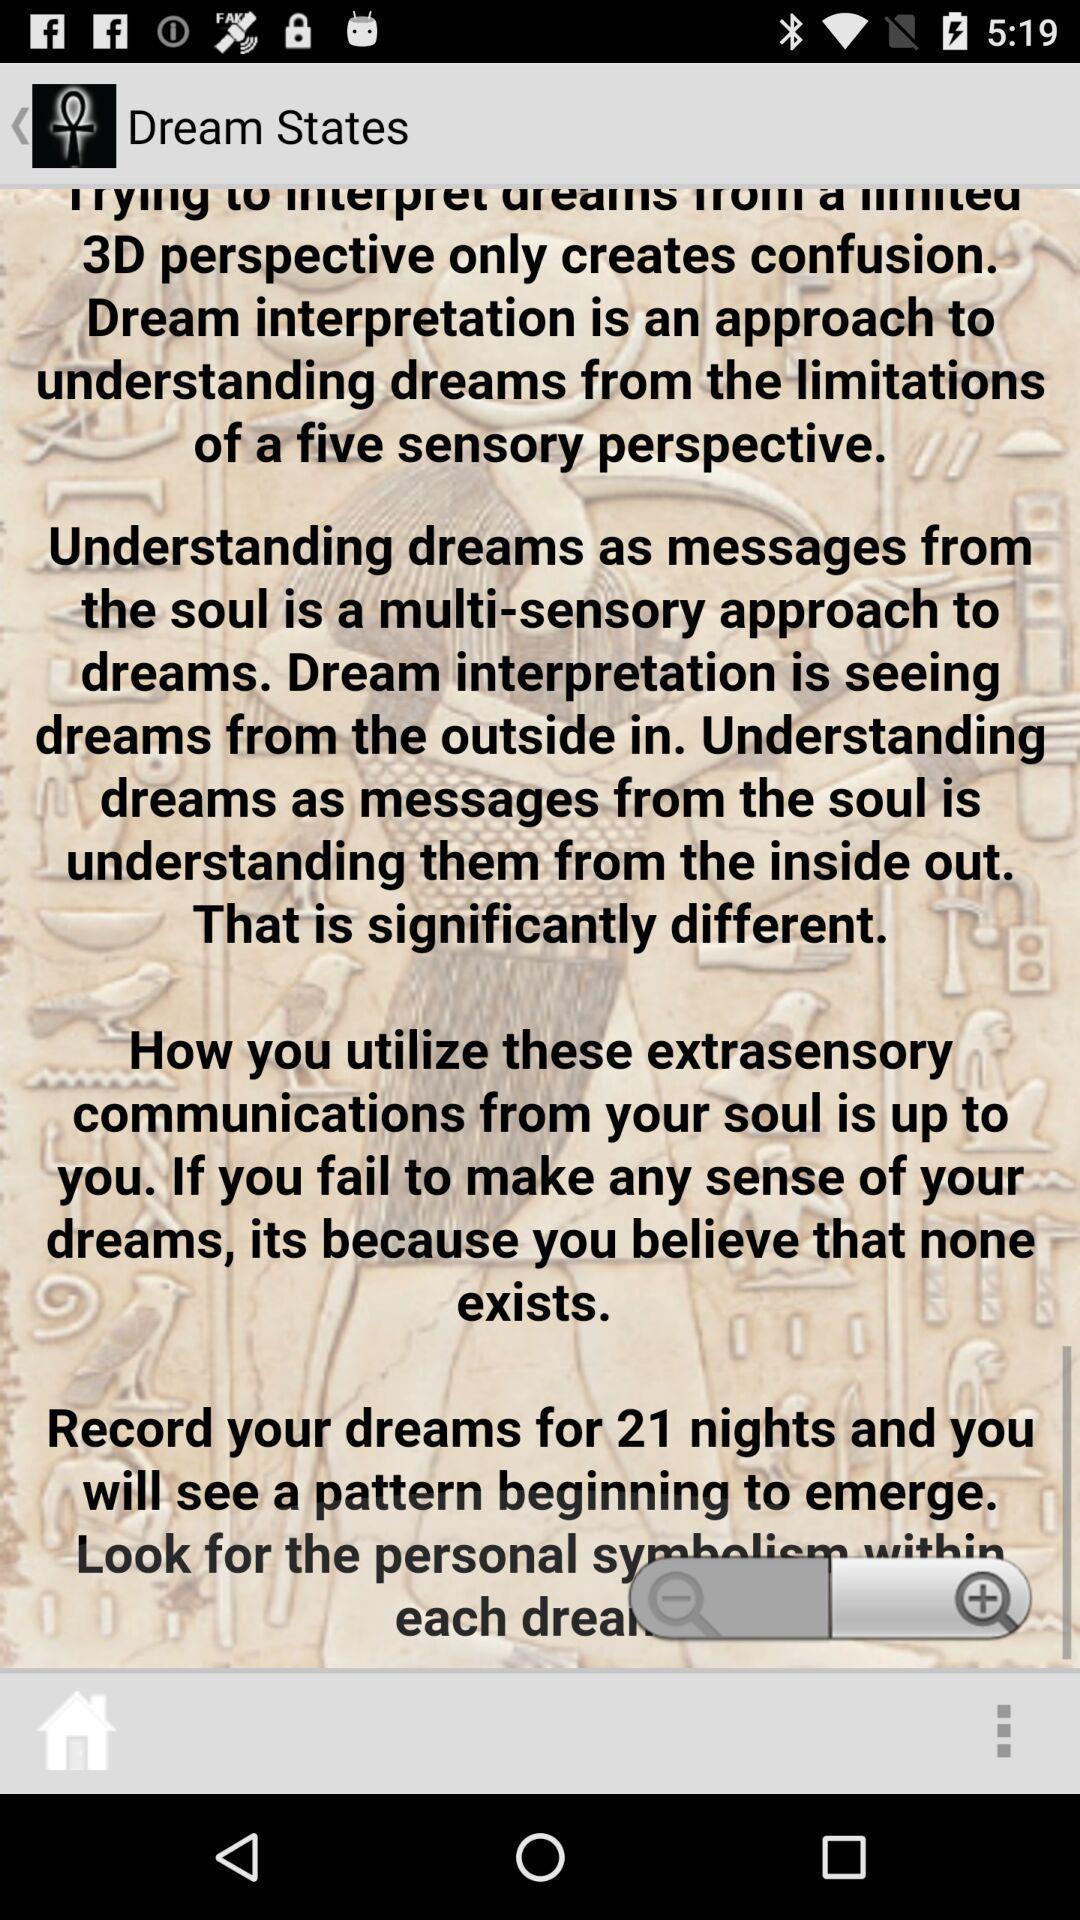Explain what's happening in this screen capture. Page showing dream states. 